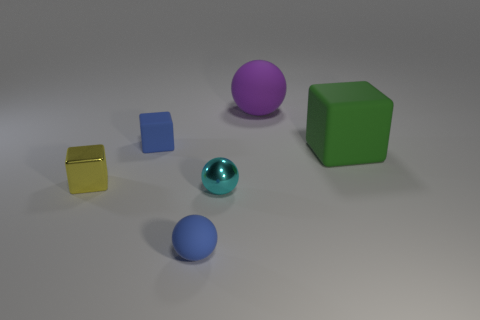Subtract all small matte cubes. How many cubes are left? 2 Add 2 small blue rubber spheres. How many objects exist? 8 Subtract 1 spheres. How many spheres are left? 2 Add 3 yellow metal things. How many yellow metal things exist? 4 Subtract 1 green blocks. How many objects are left? 5 Subtract all brown blocks. Subtract all red cylinders. How many blocks are left? 3 Subtract all metallic things. Subtract all yellow metal cubes. How many objects are left? 3 Add 5 tiny blue things. How many tiny blue things are left? 7 